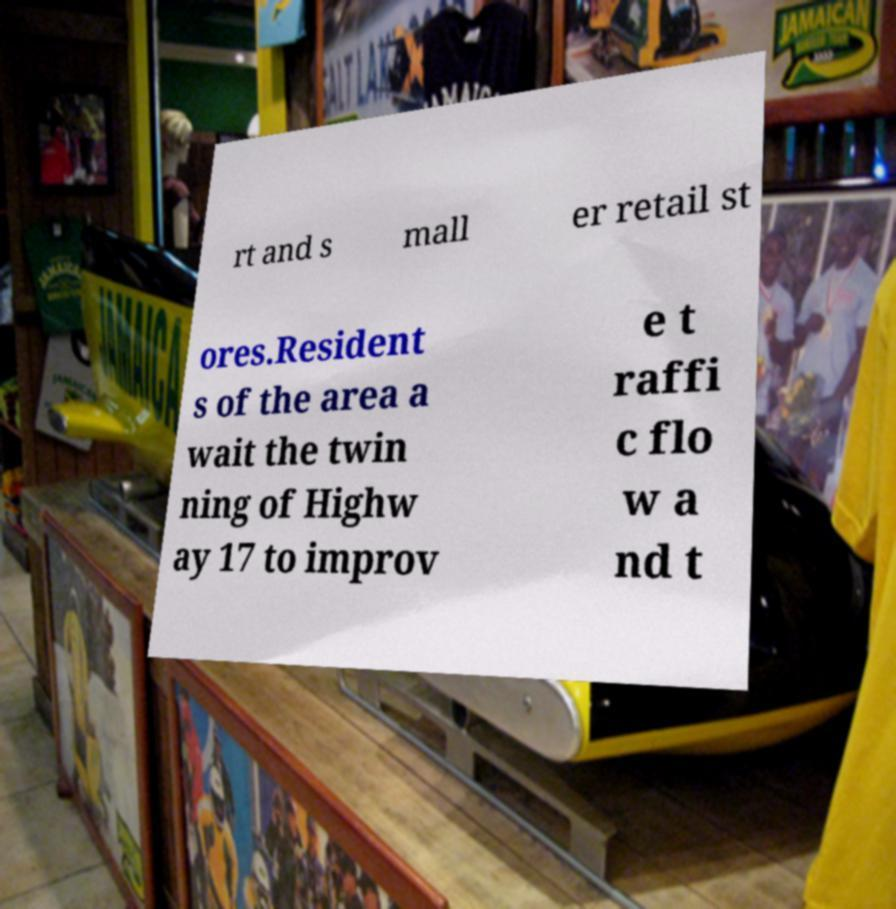Can you read and provide the text displayed in the image?This photo seems to have some interesting text. Can you extract and type it out for me? rt and s mall er retail st ores.Resident s of the area a wait the twin ning of Highw ay 17 to improv e t raffi c flo w a nd t 